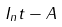<formula> <loc_0><loc_0><loc_500><loc_500>I _ { n } t - A</formula> 